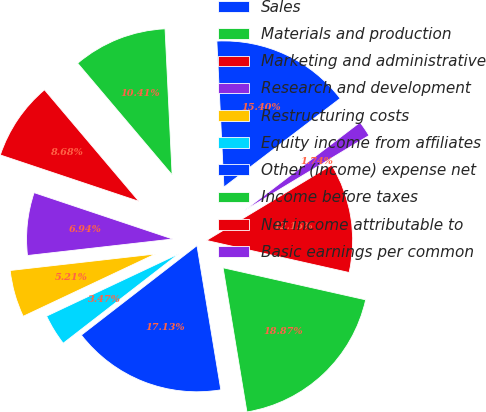Convert chart to OTSL. <chart><loc_0><loc_0><loc_500><loc_500><pie_chart><fcel>Sales<fcel>Materials and production<fcel>Marketing and administrative<fcel>Research and development<fcel>Restructuring costs<fcel>Equity income from affiliates<fcel>Other (income) expense net<fcel>Income before taxes<fcel>Net income attributable to<fcel>Basic earnings per common<nl><fcel>15.4%<fcel>10.41%<fcel>8.68%<fcel>6.94%<fcel>5.21%<fcel>3.47%<fcel>17.13%<fcel>18.87%<fcel>12.15%<fcel>1.74%<nl></chart> 